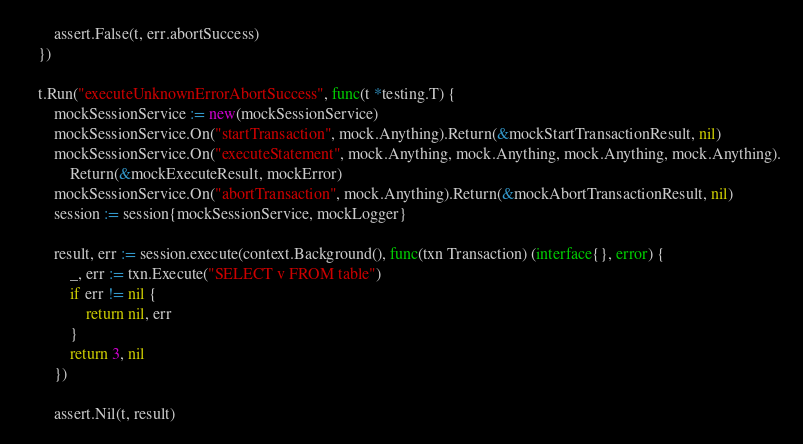Convert code to text. <code><loc_0><loc_0><loc_500><loc_500><_Go_>		assert.False(t, err.abortSuccess)
	})

	t.Run("executeUnknownErrorAbortSuccess", func(t *testing.T) {
		mockSessionService := new(mockSessionService)
		mockSessionService.On("startTransaction", mock.Anything).Return(&mockStartTransactionResult, nil)
		mockSessionService.On("executeStatement", mock.Anything, mock.Anything, mock.Anything, mock.Anything).
			Return(&mockExecuteResult, mockError)
		mockSessionService.On("abortTransaction", mock.Anything).Return(&mockAbortTransactionResult, nil)
		session := session{mockSessionService, mockLogger}

		result, err := session.execute(context.Background(), func(txn Transaction) (interface{}, error) {
			_, err := txn.Execute("SELECT v FROM table")
			if err != nil {
				return nil, err
			}
			return 3, nil
		})

		assert.Nil(t, result)</code> 